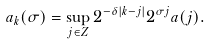Convert formula to latex. <formula><loc_0><loc_0><loc_500><loc_500>a _ { k } ( \sigma ) = \sup _ { j \in Z } 2 ^ { - \delta | k - j | } 2 ^ { \sigma j } a ( j ) .</formula> 